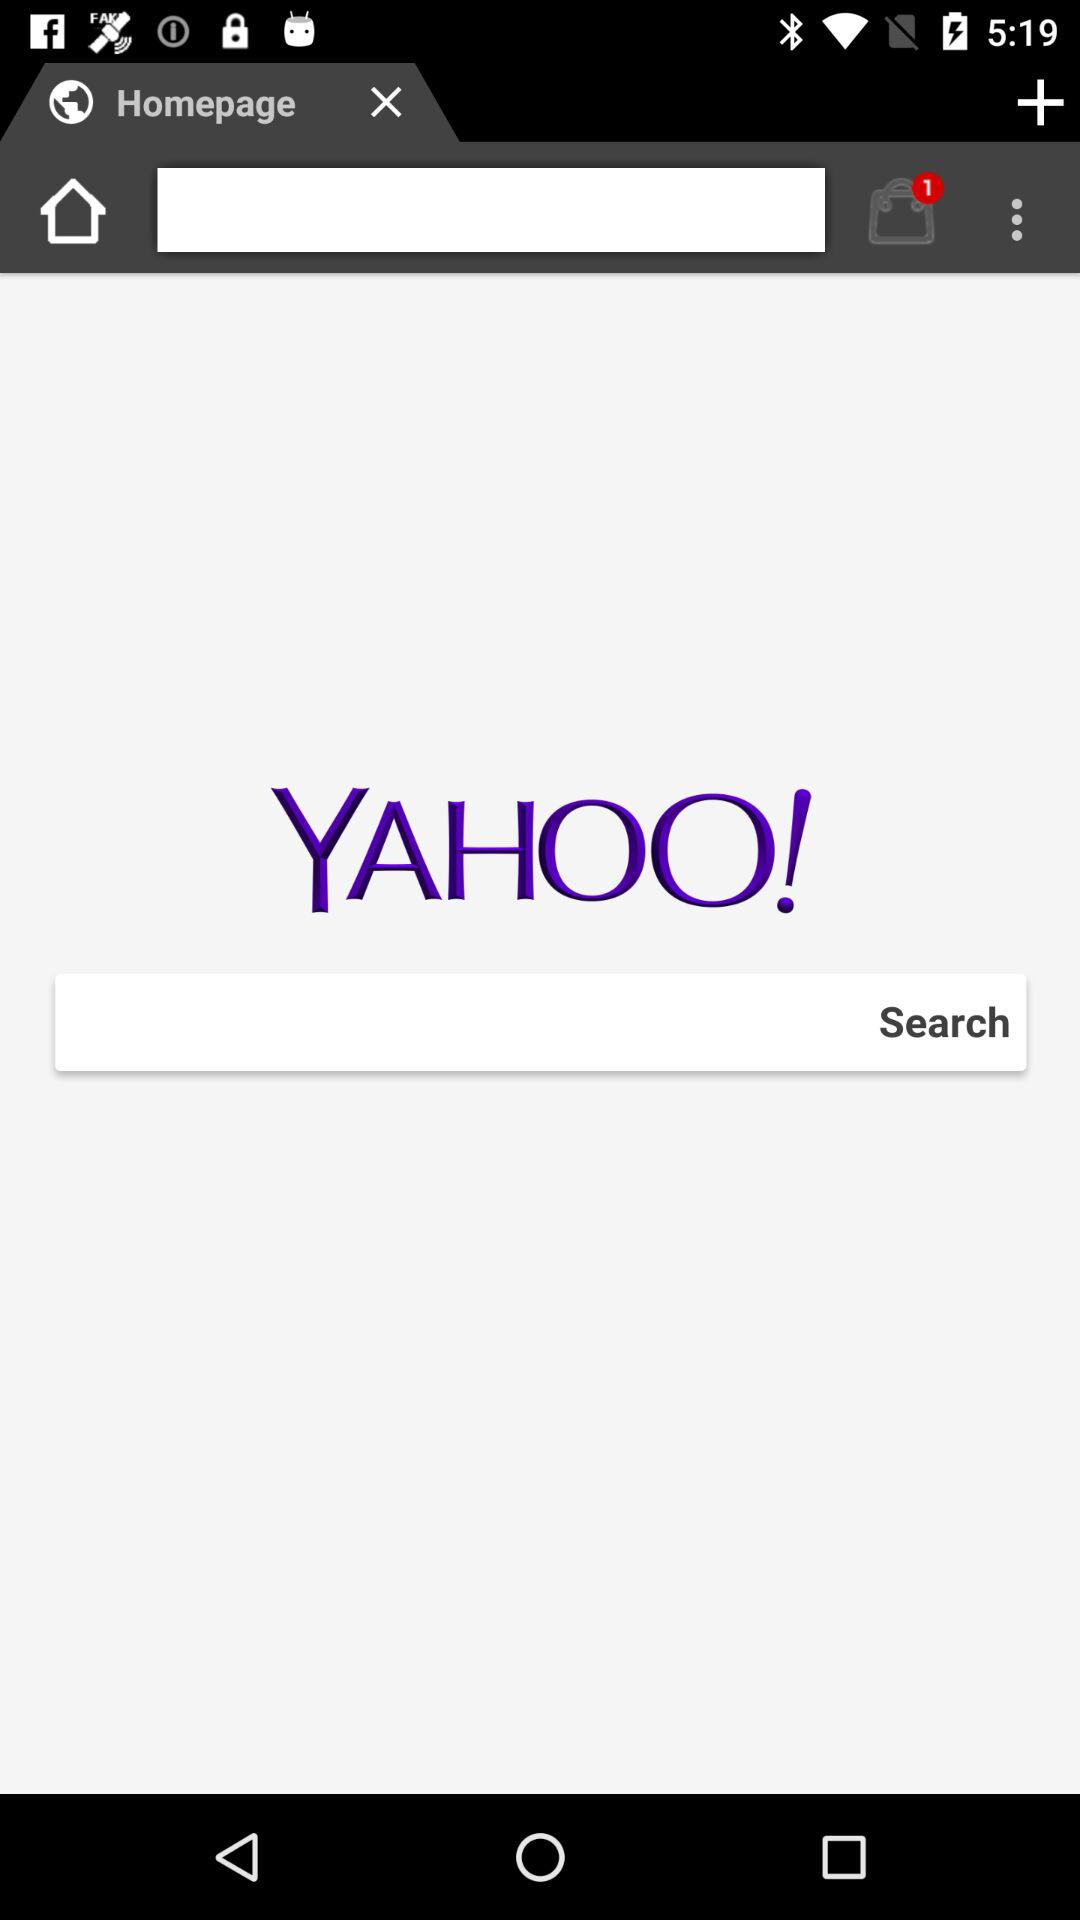How many notifications are pending? There is 1 notification pending. 